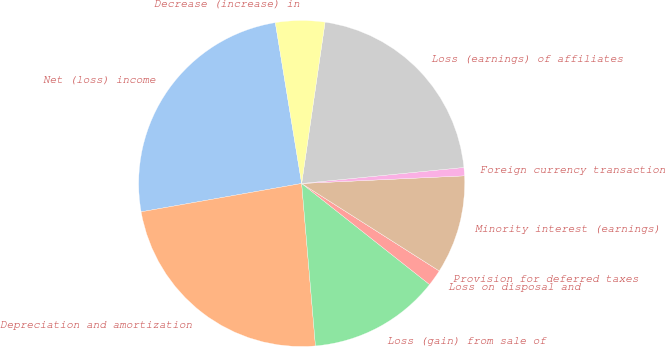Convert chart. <chart><loc_0><loc_0><loc_500><loc_500><pie_chart><fcel>Net (loss) income<fcel>Depreciation and amortization<fcel>Loss (gain) from sale of<fcel>Loss on disposal and<fcel>Provision for deferred taxes<fcel>Minority interest (earnings)<fcel>Foreign currency transaction<fcel>Loss (earnings) of affiliates<fcel>Decrease (increase) in<nl><fcel>25.2%<fcel>23.57%<fcel>13.01%<fcel>1.63%<fcel>0.0%<fcel>9.76%<fcel>0.82%<fcel>21.14%<fcel>4.88%<nl></chart> 